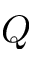<formula> <loc_0><loc_0><loc_500><loc_500>Q</formula> 